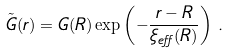Convert formula to latex. <formula><loc_0><loc_0><loc_500><loc_500>\tilde { G } ( r ) = G ( R ) \exp \left ( - \frac { r - R } { \xi _ { e f f } ( R ) } \right ) \, .</formula> 